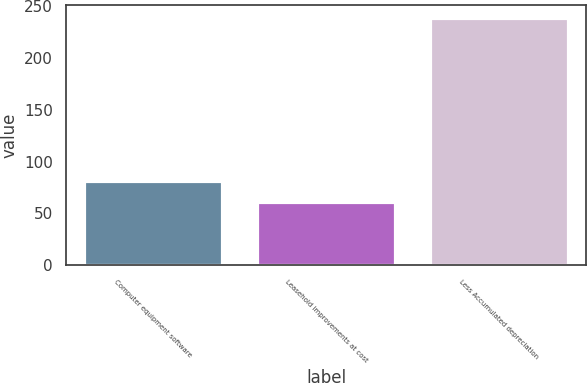Convert chart to OTSL. <chart><loc_0><loc_0><loc_500><loc_500><bar_chart><fcel>Computer equipment software<fcel>Leasehold improvements at cost<fcel>Less Accumulated depreciation<nl><fcel>80.87<fcel>61.2<fcel>238.9<nl></chart> 